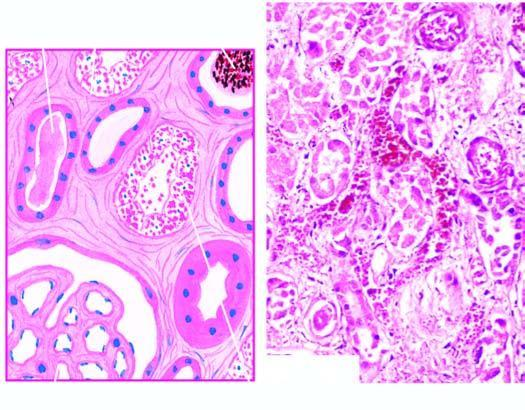what are the affected regions lined by?
Answer the question using a single word or phrase. Regenerating thin and flat epithelium 